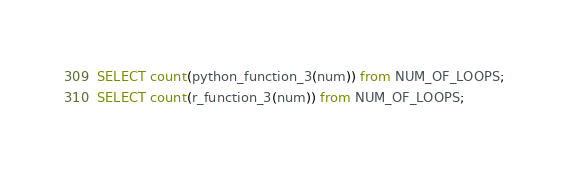<code> <loc_0><loc_0><loc_500><loc_500><_SQL_>SELECT count(python_function_3(num)) from NUM_OF_LOOPS;
SELECT count(r_function_3(num)) from NUM_OF_LOOPS;
</code> 